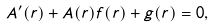<formula> <loc_0><loc_0><loc_500><loc_500>A ^ { \prime } ( r ) + A ( r ) f ( r ) + g ( r ) = 0 ,</formula> 